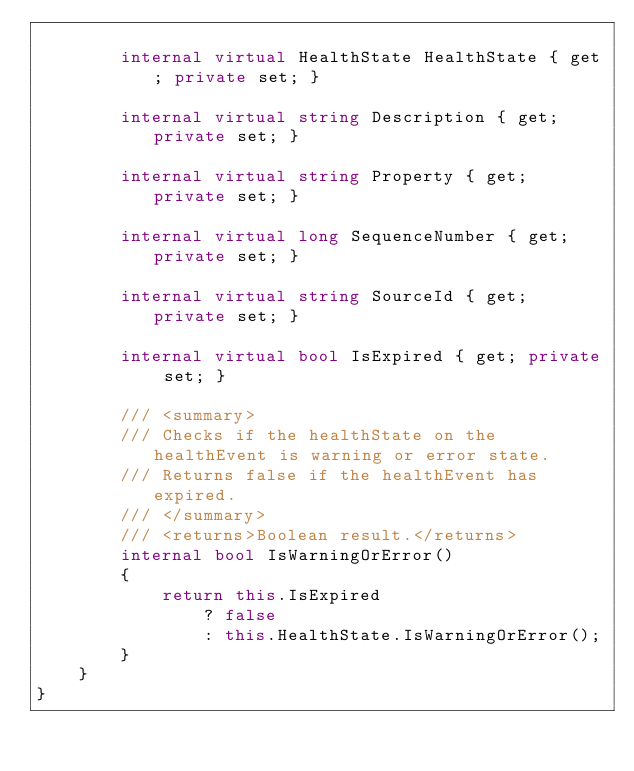<code> <loc_0><loc_0><loc_500><loc_500><_C#_>
        internal virtual HealthState HealthState { get; private set; }

        internal virtual string Description { get; private set; }

        internal virtual string Property { get; private set; }

        internal virtual long SequenceNumber { get; private set; }

        internal virtual string SourceId { get; private set; }

        internal virtual bool IsExpired { get; private set; }

        /// <summary>
        /// Checks if the healthState on the healthEvent is warning or error state.
        /// Returns false if the healthEvent has expired.
        /// </summary>
        /// <returns>Boolean result.</returns>
        internal bool IsWarningOrError()
        {
            return this.IsExpired
                ? false
                : this.HealthState.IsWarningOrError();
        }
    }
}</code> 